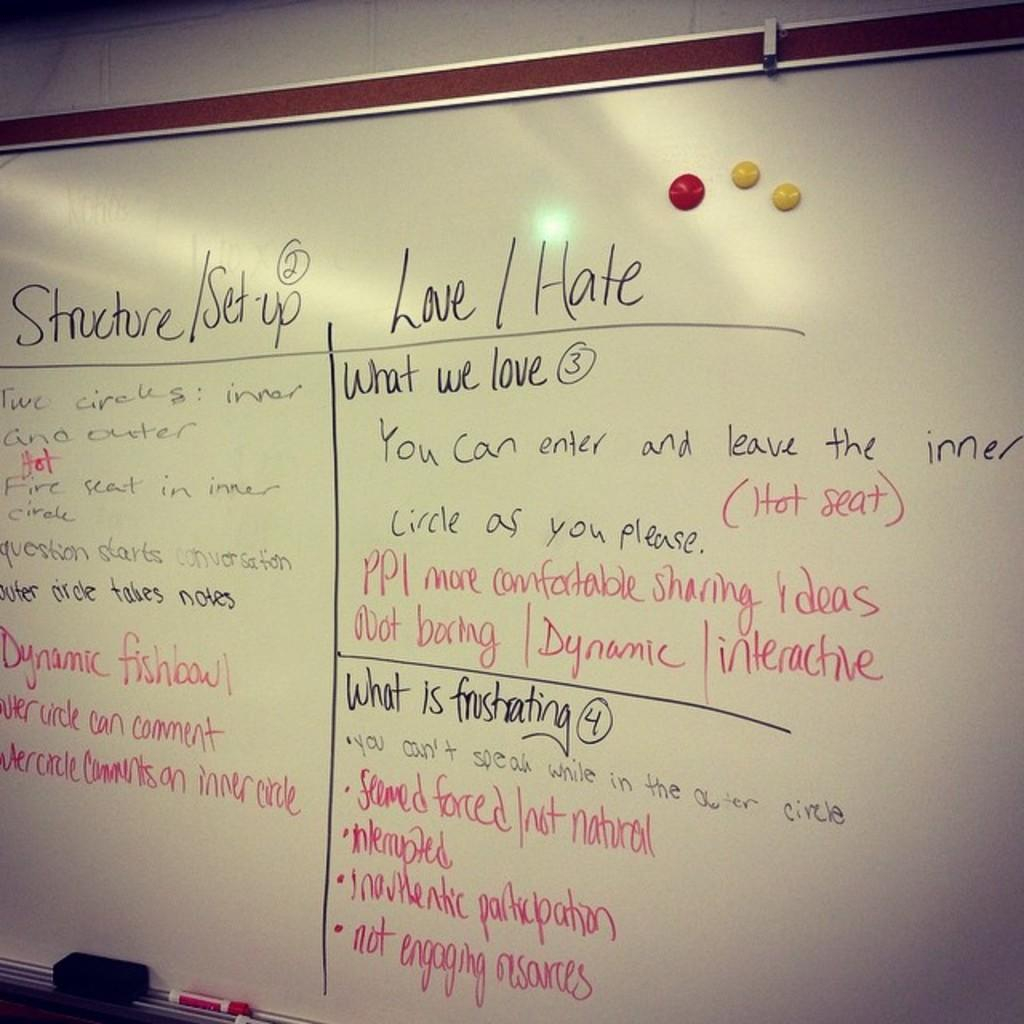<image>
Give a short and clear explanation of the subsequent image. A list on a white board includes things the writer loves and hates. 